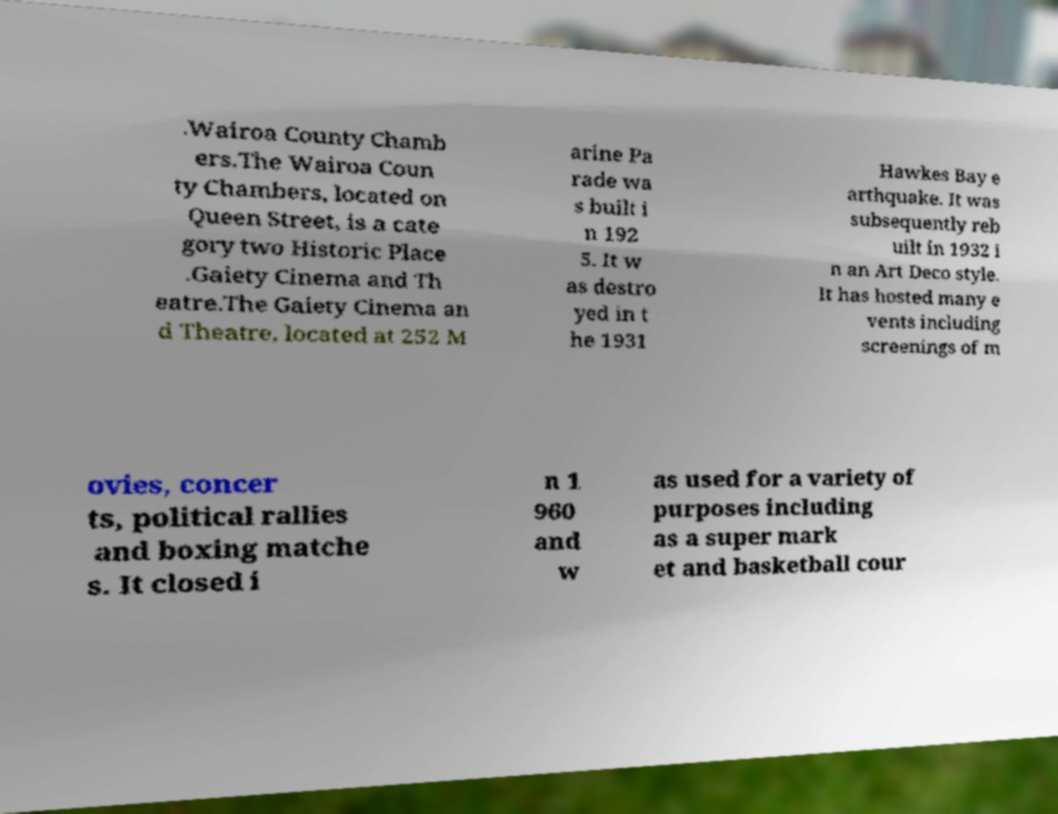I need the written content from this picture converted into text. Can you do that? .Wairoa County Chamb ers.The Wairoa Coun ty Chambers, located on Queen Street, is a cate gory two Historic Place .Gaiety Cinema and Th eatre.The Gaiety Cinema an d Theatre, located at 252 M arine Pa rade wa s built i n 192 5. It w as destro yed in t he 1931 Hawkes Bay e arthquake. It was subsequently reb uilt in 1932 i n an Art Deco style. It has hosted many e vents including screenings of m ovies, concer ts, political rallies and boxing matche s. It closed i n 1 960 and w as used for a variety of purposes including as a super mark et and basketball cour 